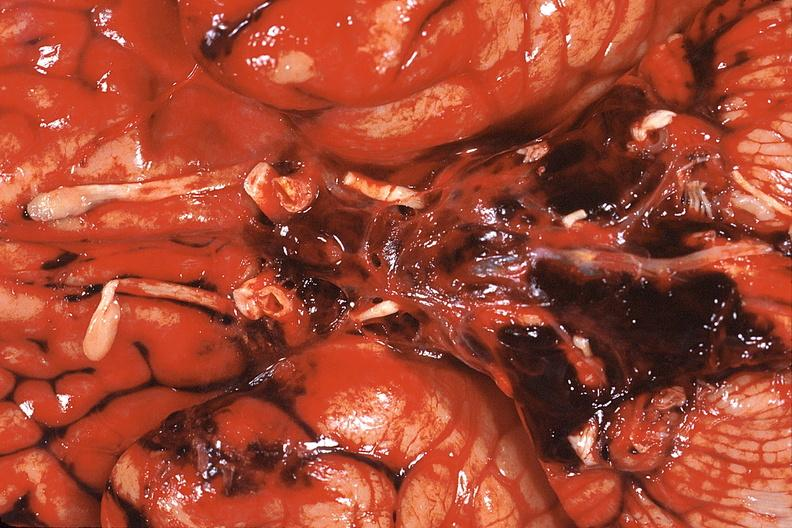what is present?
Answer the question using a single word or phrase. Nervous 